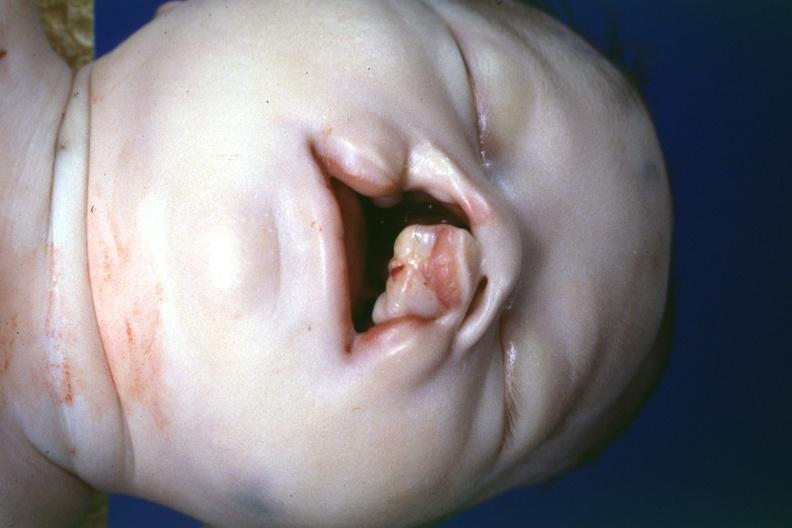what is present?
Answer the question using a single word or phrase. Cleft palate 